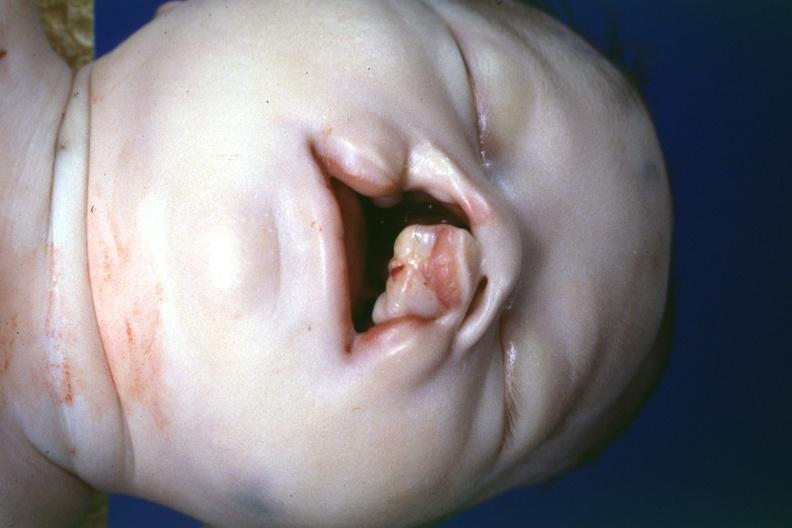what is present?
Answer the question using a single word or phrase. Cleft palate 